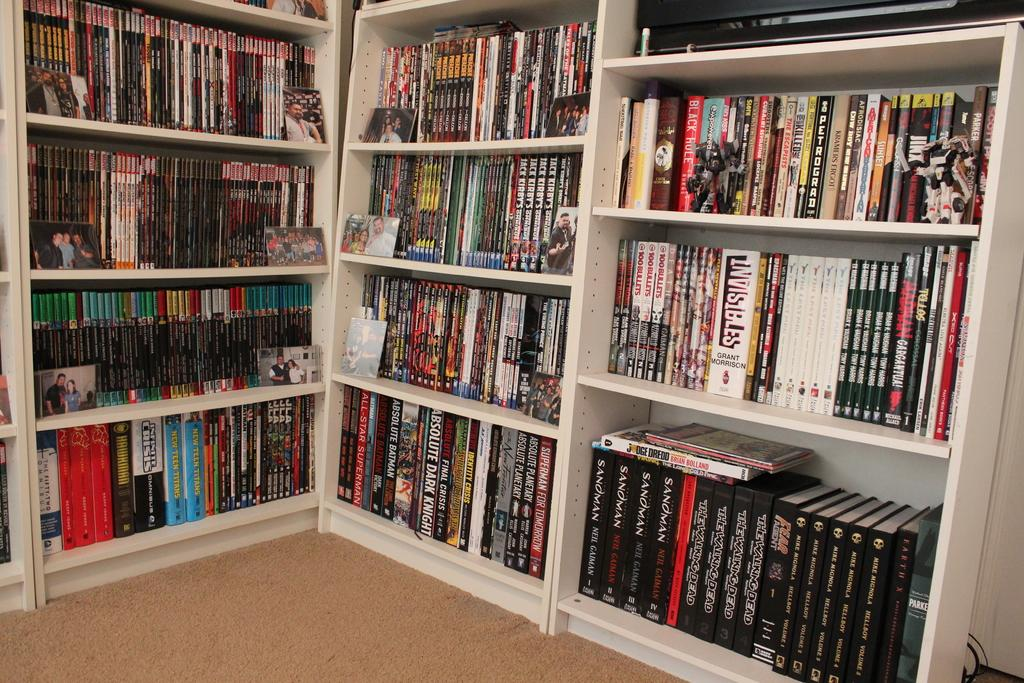<image>
Provide a brief description of the given image. Bookshelves containg many books some are written by Neil Gaiman. 